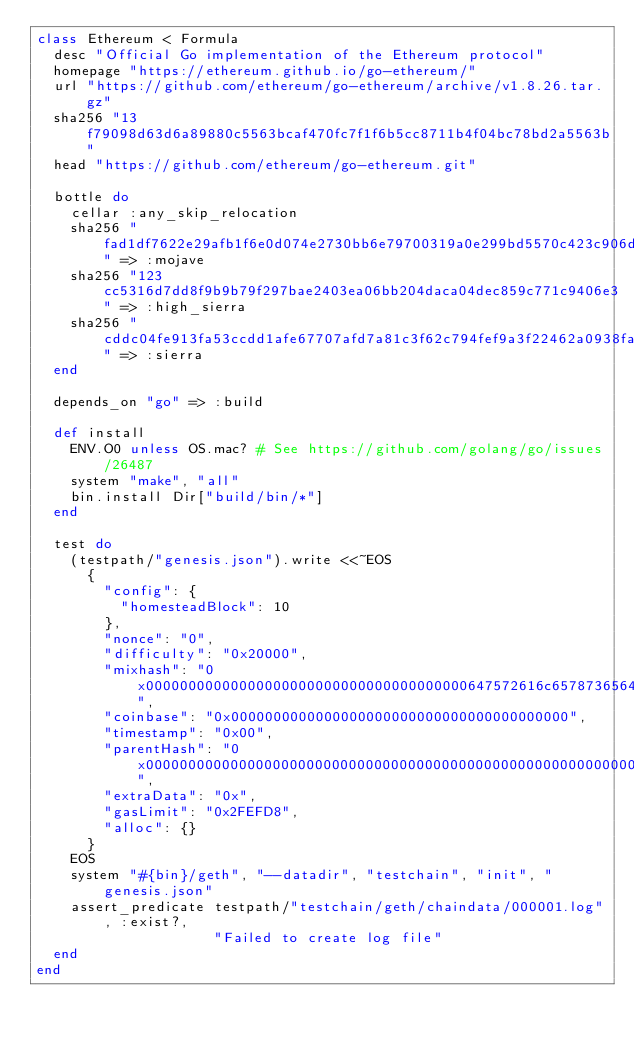Convert code to text. <code><loc_0><loc_0><loc_500><loc_500><_Ruby_>class Ethereum < Formula
  desc "Official Go implementation of the Ethereum protocol"
  homepage "https://ethereum.github.io/go-ethereum/"
  url "https://github.com/ethereum/go-ethereum/archive/v1.8.26.tar.gz"
  sha256 "13f79098d63d6a89880c5563bcaf470fc7f1f6b5cc8711b4f04bc78bd2a5563b"
  head "https://github.com/ethereum/go-ethereum.git"

  bottle do
    cellar :any_skip_relocation
    sha256 "fad1df7622e29afb1f6e0d074e2730bb6e79700319a0e299bd5570c423c906de" => :mojave
    sha256 "123cc5316d7dd8f9b9b79f297bae2403ea06bb204daca04dec859c771c9406e3" => :high_sierra
    sha256 "cddc04fe913fa53ccdd1afe67707afd7a81c3f62c794fef9a3f22462a0938faa" => :sierra
  end

  depends_on "go" => :build

  def install
    ENV.O0 unless OS.mac? # See https://github.com/golang/go/issues/26487
    system "make", "all"
    bin.install Dir["build/bin/*"]
  end

  test do
    (testpath/"genesis.json").write <<~EOS
      {
        "config": {
          "homesteadBlock": 10
        },
        "nonce": "0",
        "difficulty": "0x20000",
        "mixhash": "0x00000000000000000000000000000000000000647572616c65787365646c6578",
        "coinbase": "0x0000000000000000000000000000000000000000",
        "timestamp": "0x00",
        "parentHash": "0x0000000000000000000000000000000000000000000000000000000000000000",
        "extraData": "0x",
        "gasLimit": "0x2FEFD8",
        "alloc": {}
      }
    EOS
    system "#{bin}/geth", "--datadir", "testchain", "init", "genesis.json"
    assert_predicate testpath/"testchain/geth/chaindata/000001.log", :exist?,
                     "Failed to create log file"
  end
end
</code> 